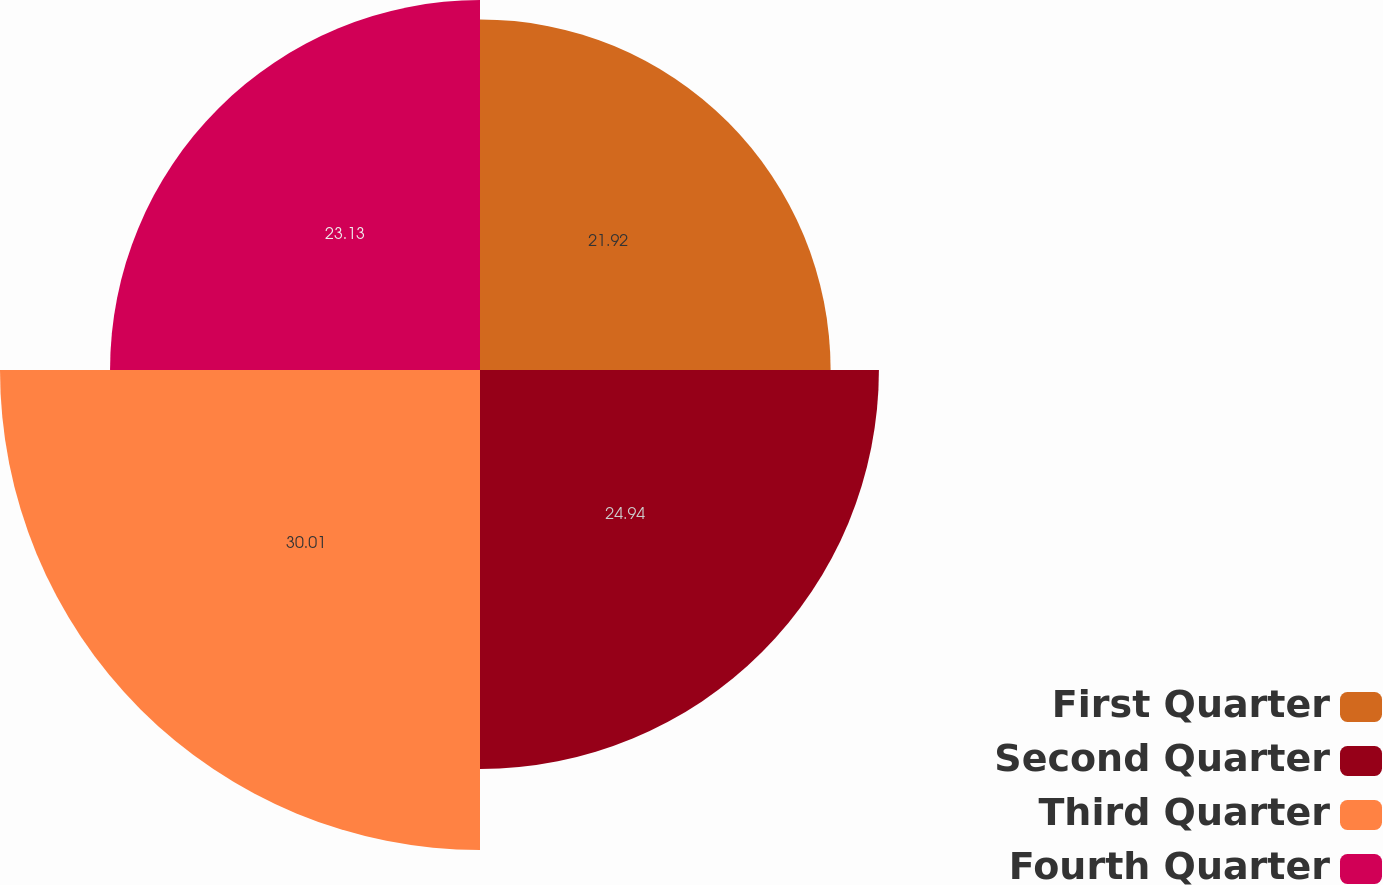Convert chart to OTSL. <chart><loc_0><loc_0><loc_500><loc_500><pie_chart><fcel>First Quarter<fcel>Second Quarter<fcel>Third Quarter<fcel>Fourth Quarter<nl><fcel>21.92%<fcel>24.94%<fcel>30.01%<fcel>23.13%<nl></chart> 